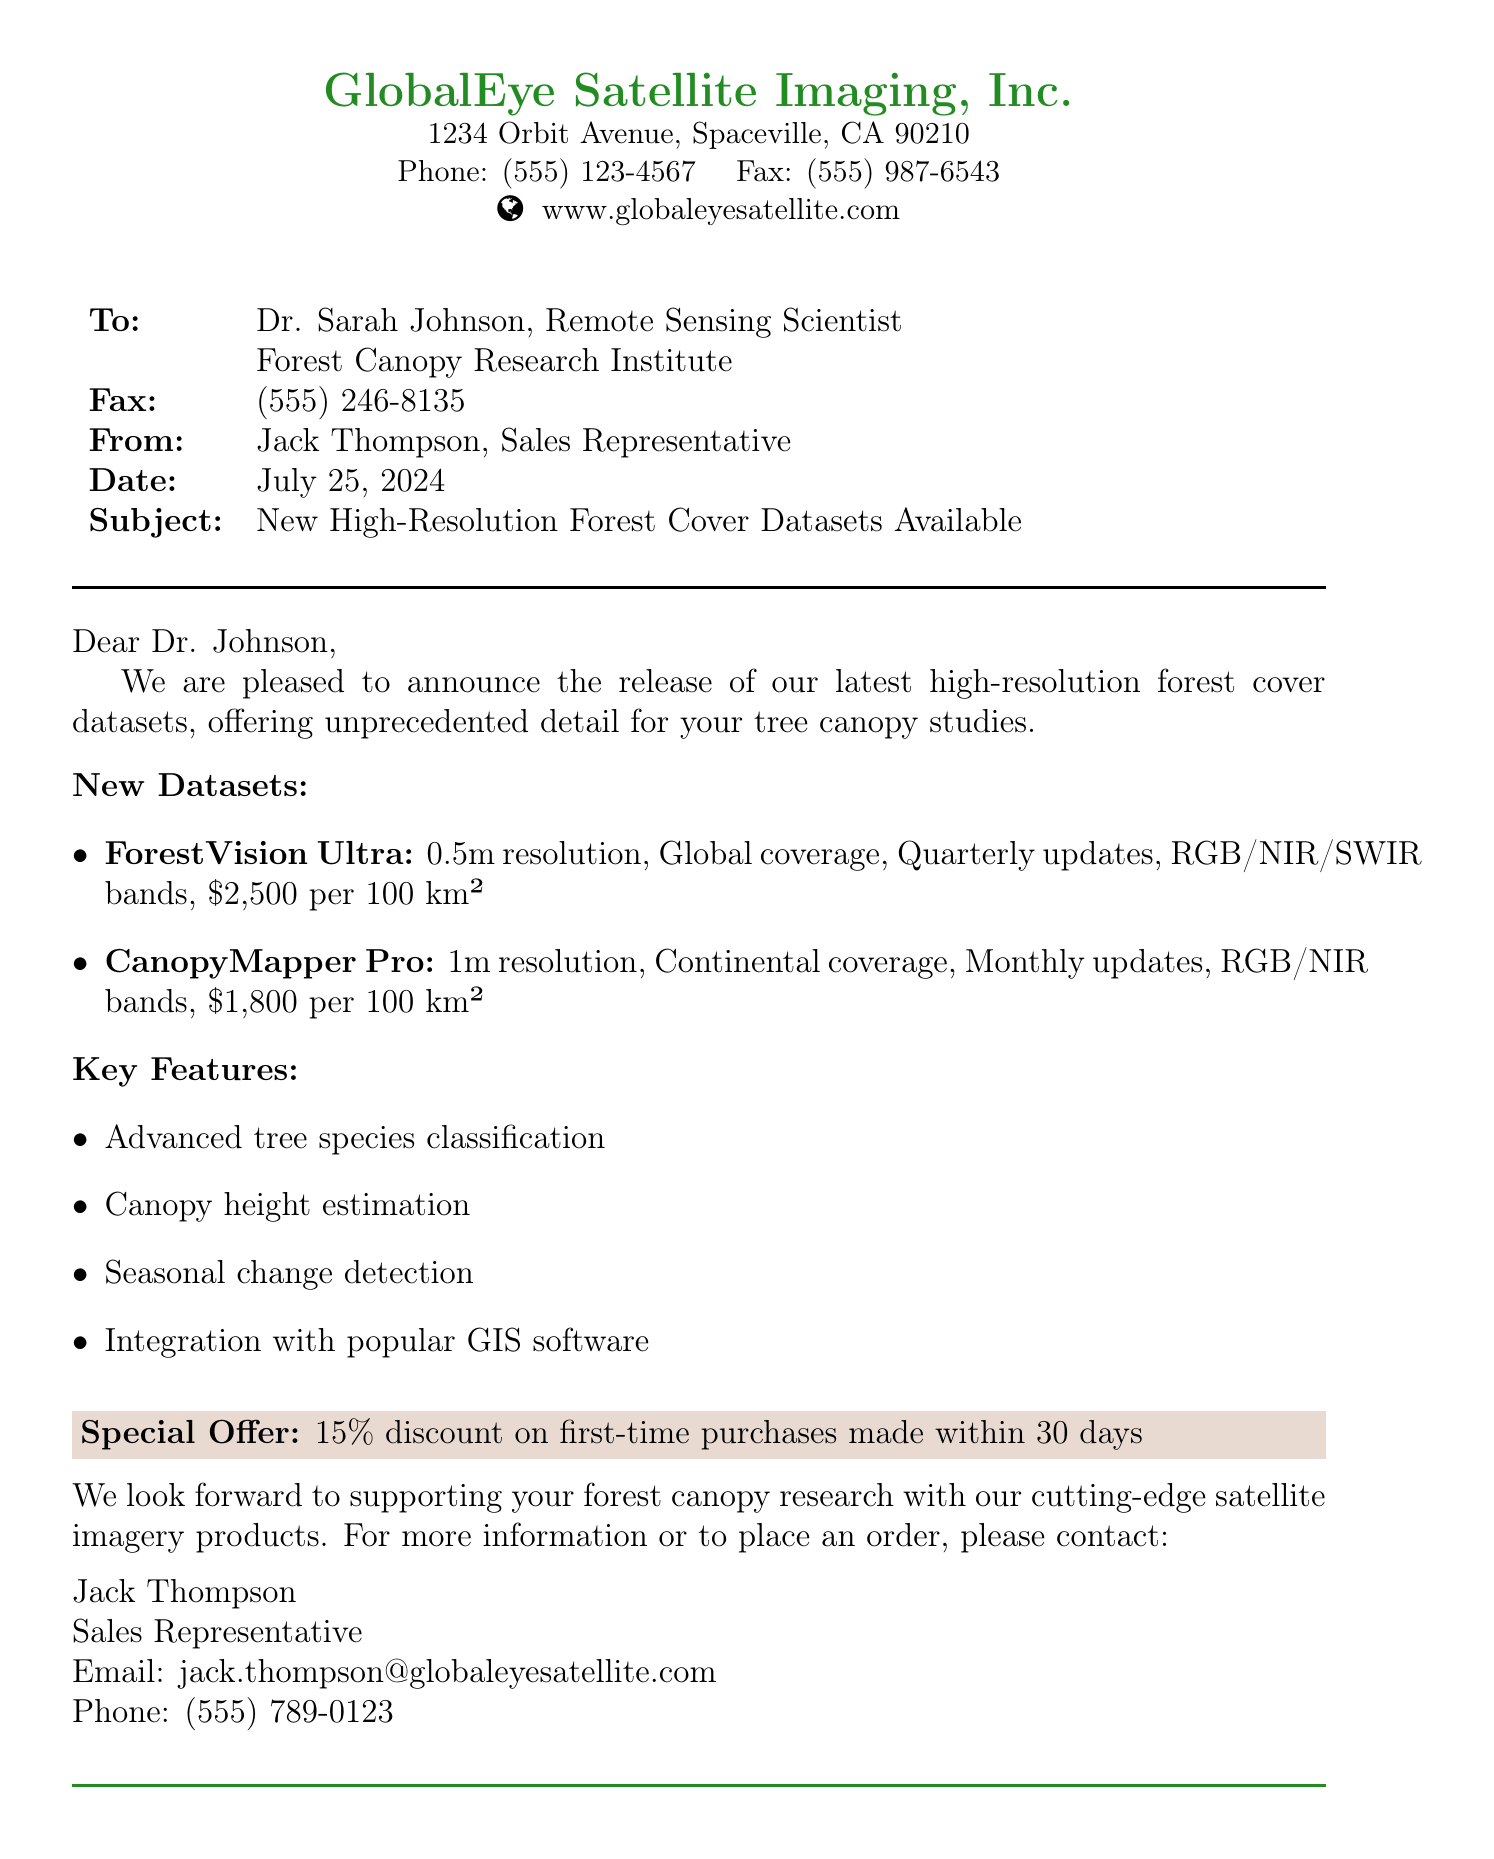What is the name of the satellite imagery provider? The name of the satellite imagery provider is mentioned at the beginning of the document.
Answer: GlobalEye Satellite Imaging, Inc What is the resolution of the ForestVision Ultra dataset? The resolution of the ForestVision Ultra dataset is specified in the document under new datasets.
Answer: 0.5m What is the cost of CanopyMapper Pro per 100 km²? The cost of CanopyMapper Pro is listed in the document's pricing section.
Answer: $1,800 How often are updates provided for ForestVision Ultra? The frequency of updates for ForestVision Ultra is highlighted in the list of new datasets.
Answer: Quarterly What discount is offered on first-time purchases? The special offer details regarding the discount are provided in a highlighted section of the document.
Answer: 15% Who should be contacted for more information? The contact information for inquiries is mentioned at the end of the fax.
Answer: Jack Thompson What kind of updates does CanopyMapper Pro offer? The type of updates for CanopyMapper Pro is detailed in its dataset description.
Answer: Monthly What features are included with the new datasets? The key features of the new datasets are listed under that section in the document.
Answer: Advanced tree species classification, Canopy height estimation, Seasonal change detection, Integration with popular GIS software What is the fax number for Dr. Sarah Johnson? The fax number for Dr. Sarah Johnson is noted in the document.
Answer: (555) 246-8135 